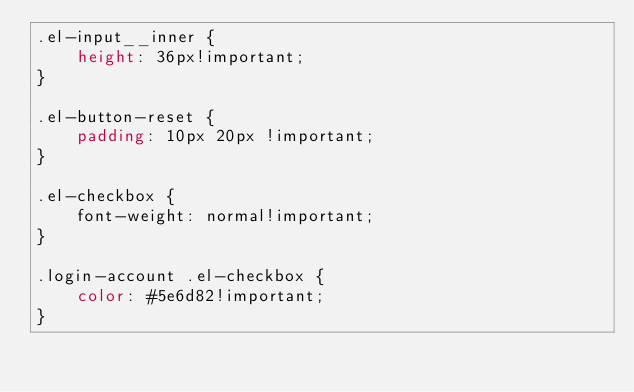Convert code to text. <code><loc_0><loc_0><loc_500><loc_500><_CSS_>.el-input__inner {
    height: 36px!important;
}

.el-button-reset {
    padding: 10px 20px !important;
}

.el-checkbox {
    font-weight: normal!important;
}

.login-account .el-checkbox {
    color: #5e6d82!important;
}</code> 